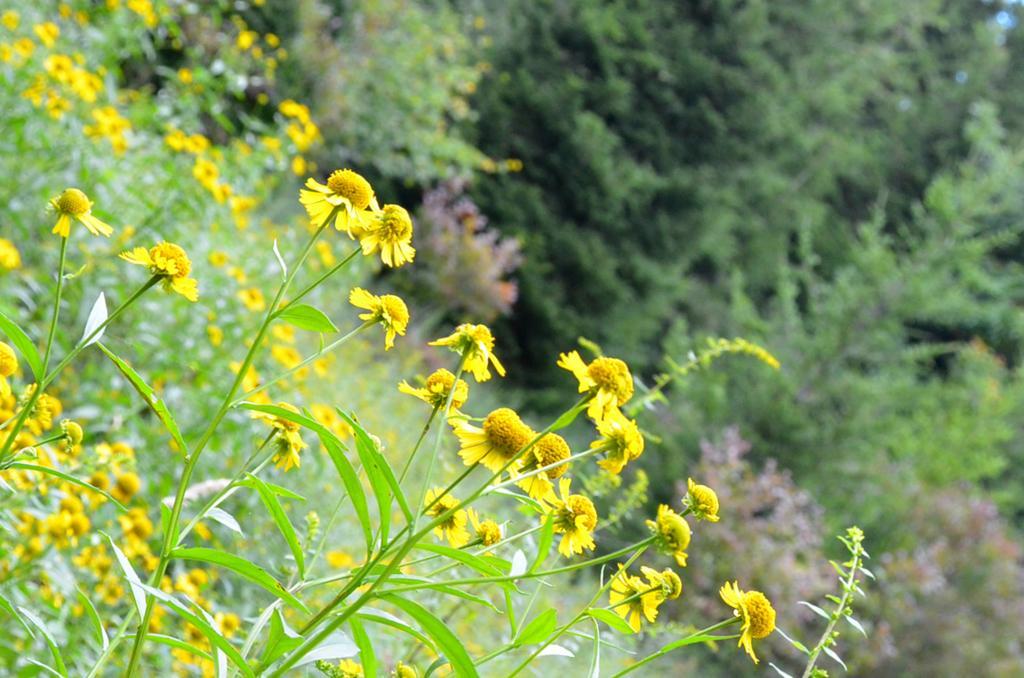Please provide a concise description of this image. This picture might be taken from outside of the city. In this image, On the left side, we can see a plant with yellow flowers. On the right side, we can see some trees. 